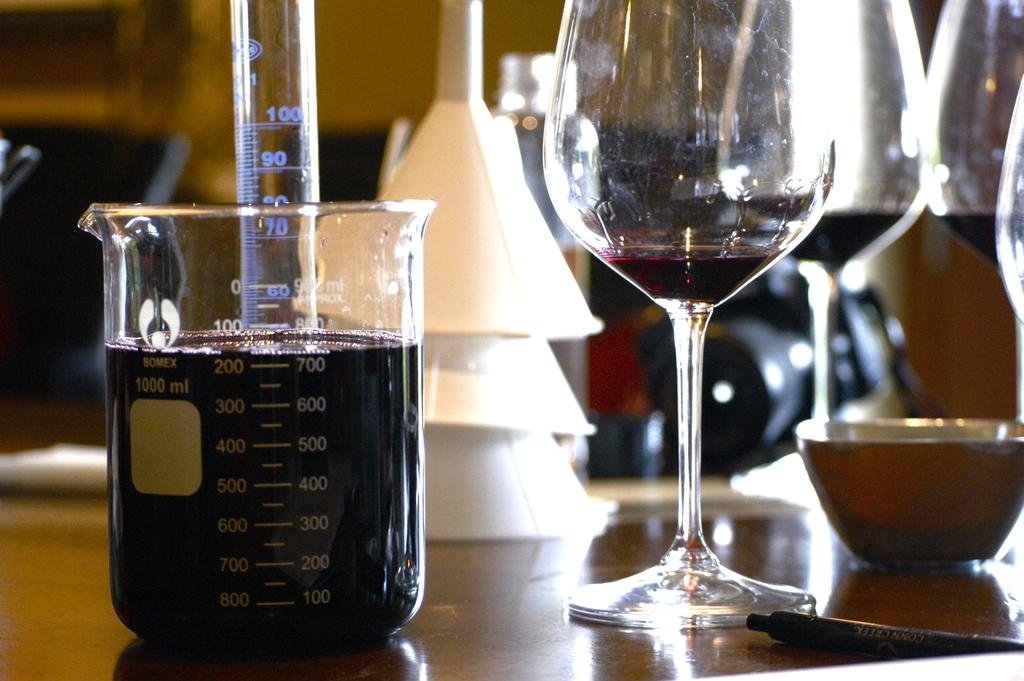<image>
Summarize the visual content of the image. Wine Glass and Beaker that is measured at 700 ML. 